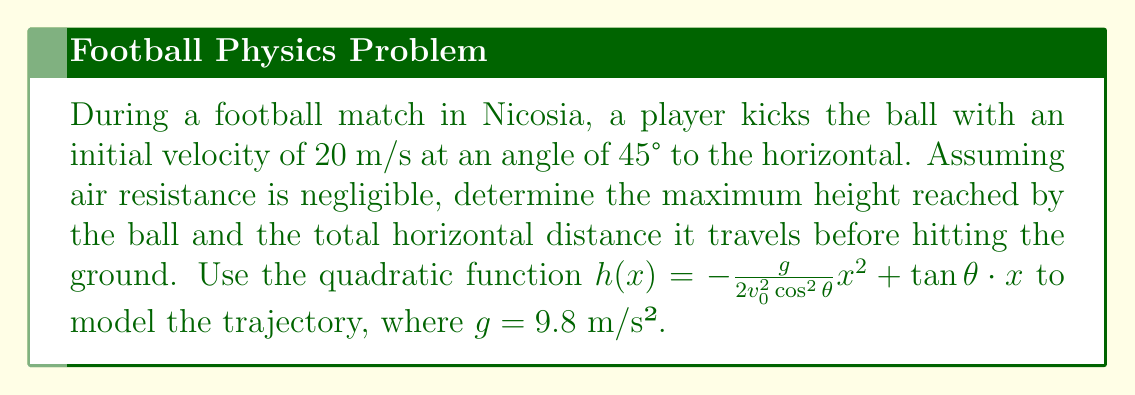Can you answer this question? Let's approach this step-by-step:

1) The trajectory of the ball is modeled by the quadratic function:
   $h(x) = -\frac{g}{2v_0^2\cos^2\theta}x^2 + \tan\theta \cdot x$

2) We're given:
   $v_0 = 20$ m/s
   $\theta = 45°$
   $g = 9.8$ m/s²

3) First, let's calculate some useful values:
   $\cos 45° = \sin 45° = \frac{1}{\sqrt{2}} \approx 0.7071$
   $\tan 45° = 1$

4) Now, let's substitute these into our equation:
   $h(x) = -\frac{9.8}{2(20^2)(0.7071^2)}x^2 + 1x$
   $h(x) = -0.0245x^2 + x$

5) To find the maximum height, we need to find the vertex of this parabola.
   The x-coordinate of the vertex is given by $x = -\frac{b}{2a}$, where $a$ and $b$ are the coefficients of $x^2$ and $x$ respectively.

   $x = -\frac{1}{2(-0.0245)} = 20.41$ m

6) The maximum height is found by plugging this x-value back into our equation:
   $h(20.41) = -0.0245(20.41^2) + 20.41 = 10.20$ m

7) For the total horizontal distance, we need to find where the ball hits the ground, i.e., where $h(x) = 0$:
   $0 = -0.0245x^2 + x$
   $x(-0.0245x + 1) = 0$
   $x = 0$ or $x = 40.82$ m

   The non-zero solution, 40.82 m, is our total horizontal distance.
Answer: Maximum height: 10.20 m; Total horizontal distance: 40.82 m 